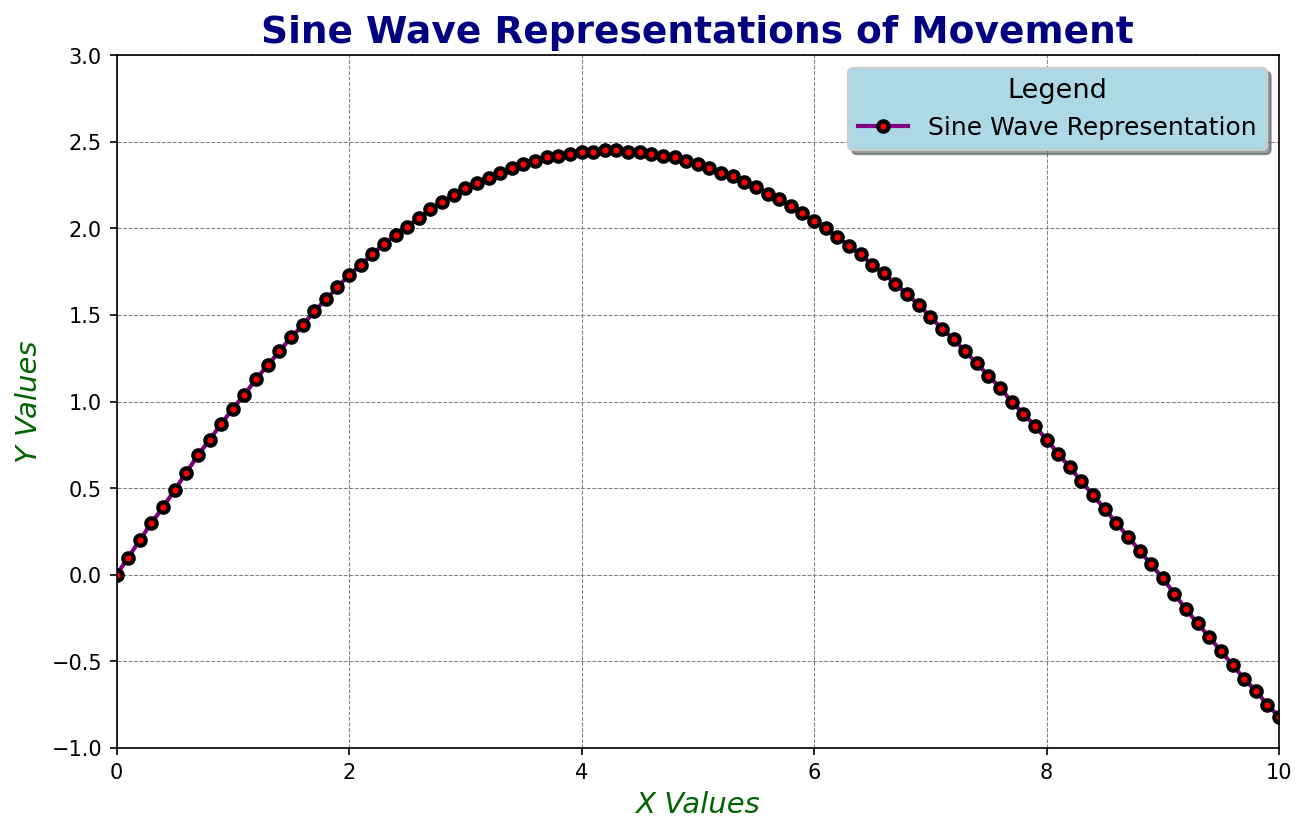What's the maximum value of the Y-axis? The Y-axis reaches its highest point where the curve peaks. From the visual inspection, the highest point on the Y-axis is at approximately 2.45.
Answer: 2.45 At approximately what X value does the Y value reach its peak? The peak value on the Y-axis visually occurs around the X value of 4.3. This can be seen where the curve reaches its highest point before starting to descend.
Answer: 4.3 Does the Y value increase or decrease at X=7? At X = 7, the Y value is approximately 1.49, and comparing it to the Y value at X=6.9 (1.56), it shows that Y is decreasing.
Answer: Decrease What is the relationship between the X value at 2 and the Y value at the same point? At X=2, the corresponding Y value is 1.73. Simply refer to the plotted value directly from the figure.
Answer: 1.73 Is the Y value equal for any two X values? If so, provide an example. Yes, the Y value is equal for X=0.77 and X=8 at a Y value of 0.78. This can be observed where the graph crosses the same Y value at different X points.
Answer: X=0.77 & X=8 At what approximate X value does the Y value first reach 1? The Y value first reaches approximately 1 at X values between 1 and 1.1 as the curve sharply ascends.
Answer: Between 1 and 1.1 How many times does the Y value cross 0? The Y value crosses 0 twice. Once at X=0 and once at approximately X=8.9, as seen where the curve intersects the X-axis.
Answer: Twice What's the average Y value for X values from 4 to 6? The average Y value can be calculated by summing the Y values from X=4 to X=6 and then dividing by the number of values. From the list: (2.44 + 2.45 + 2.44 + 2.44 + 2.43 + 2.42 + 2.41 + 2.39 + 2.37 + 2.35 + 2.32) / 11 ≈ 2.42.
Answer: 2.42 